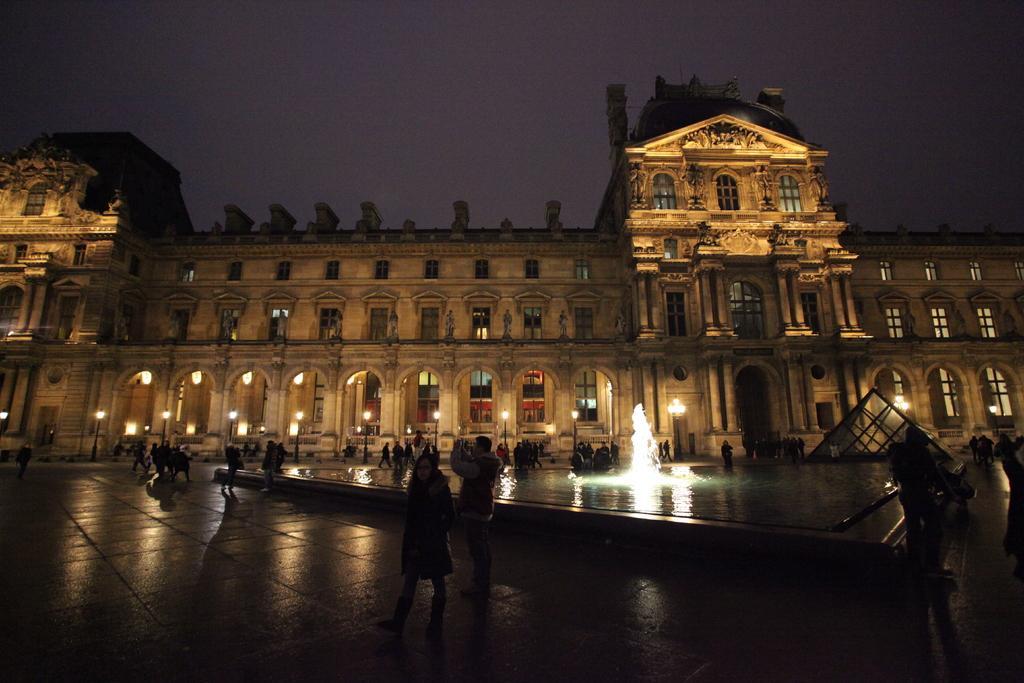Can you describe this image briefly? In this picture we can see some people are standing and some people are walking on the pathway. Behind the people there is a fountain and a building with windows. In front of the building there is an architectural structure and poles with lights. Behind the building there is the sky. 